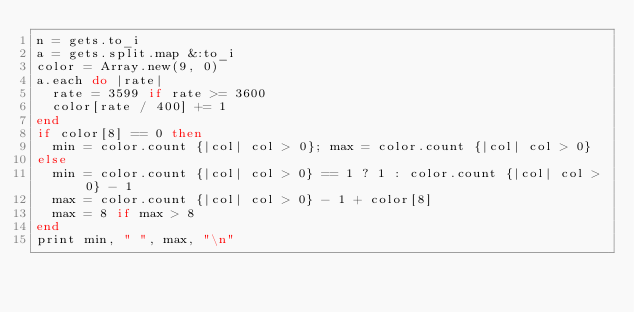<code> <loc_0><loc_0><loc_500><loc_500><_Ruby_>n = gets.to_i
a = gets.split.map &:to_i
color = Array.new(9, 0)
a.each do |rate|
  rate = 3599 if rate >= 3600
  color[rate / 400] += 1
end
if color[8] == 0 then
  min = color.count {|col| col > 0}; max = color.count {|col| col > 0}
else
  min = color.count {|col| col > 0} == 1 ? 1 : color.count {|col| col > 0} - 1
  max = color.count {|col| col > 0} - 1 + color[8]
  max = 8 if max > 8
end
print min, " ", max, "\n"
</code> 